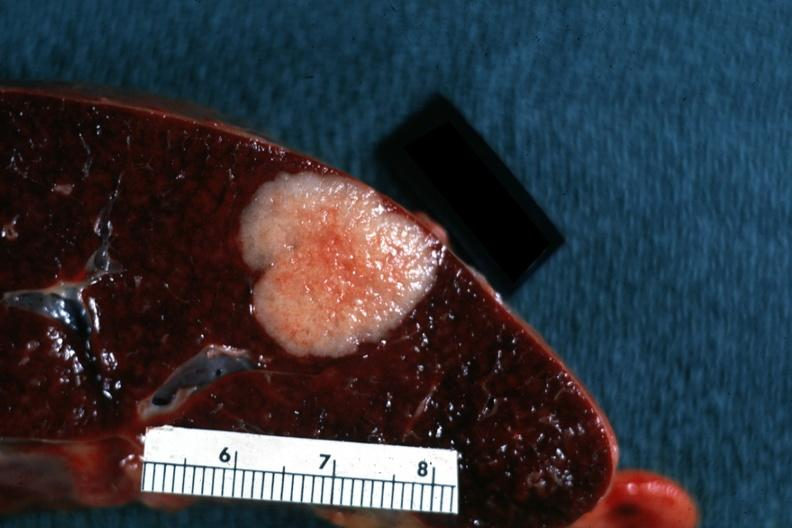what does this image show?
Answer the question using a single word or phrase. Very nice close-up shot of typical metastatic lesion primary tumor in colon 